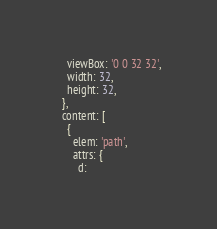Convert code to text. <code><loc_0><loc_0><loc_500><loc_500><_JavaScript_>    viewBox: '0 0 32 32',
    width: 32,
    height: 32,
  },
  content: [
    {
      elem: 'path',
      attrs: {
        d:</code> 